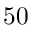<formula> <loc_0><loc_0><loc_500><loc_500>5 0</formula> 